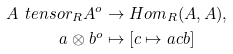Convert formula to latex. <formula><loc_0><loc_0><loc_500><loc_500>A \ t e n s o r _ { R } A ^ { o } & \to H o m _ { R } ( A , A ) , \\ a \otimes b ^ { o } & \mapsto [ c \mapsto a c b ]</formula> 